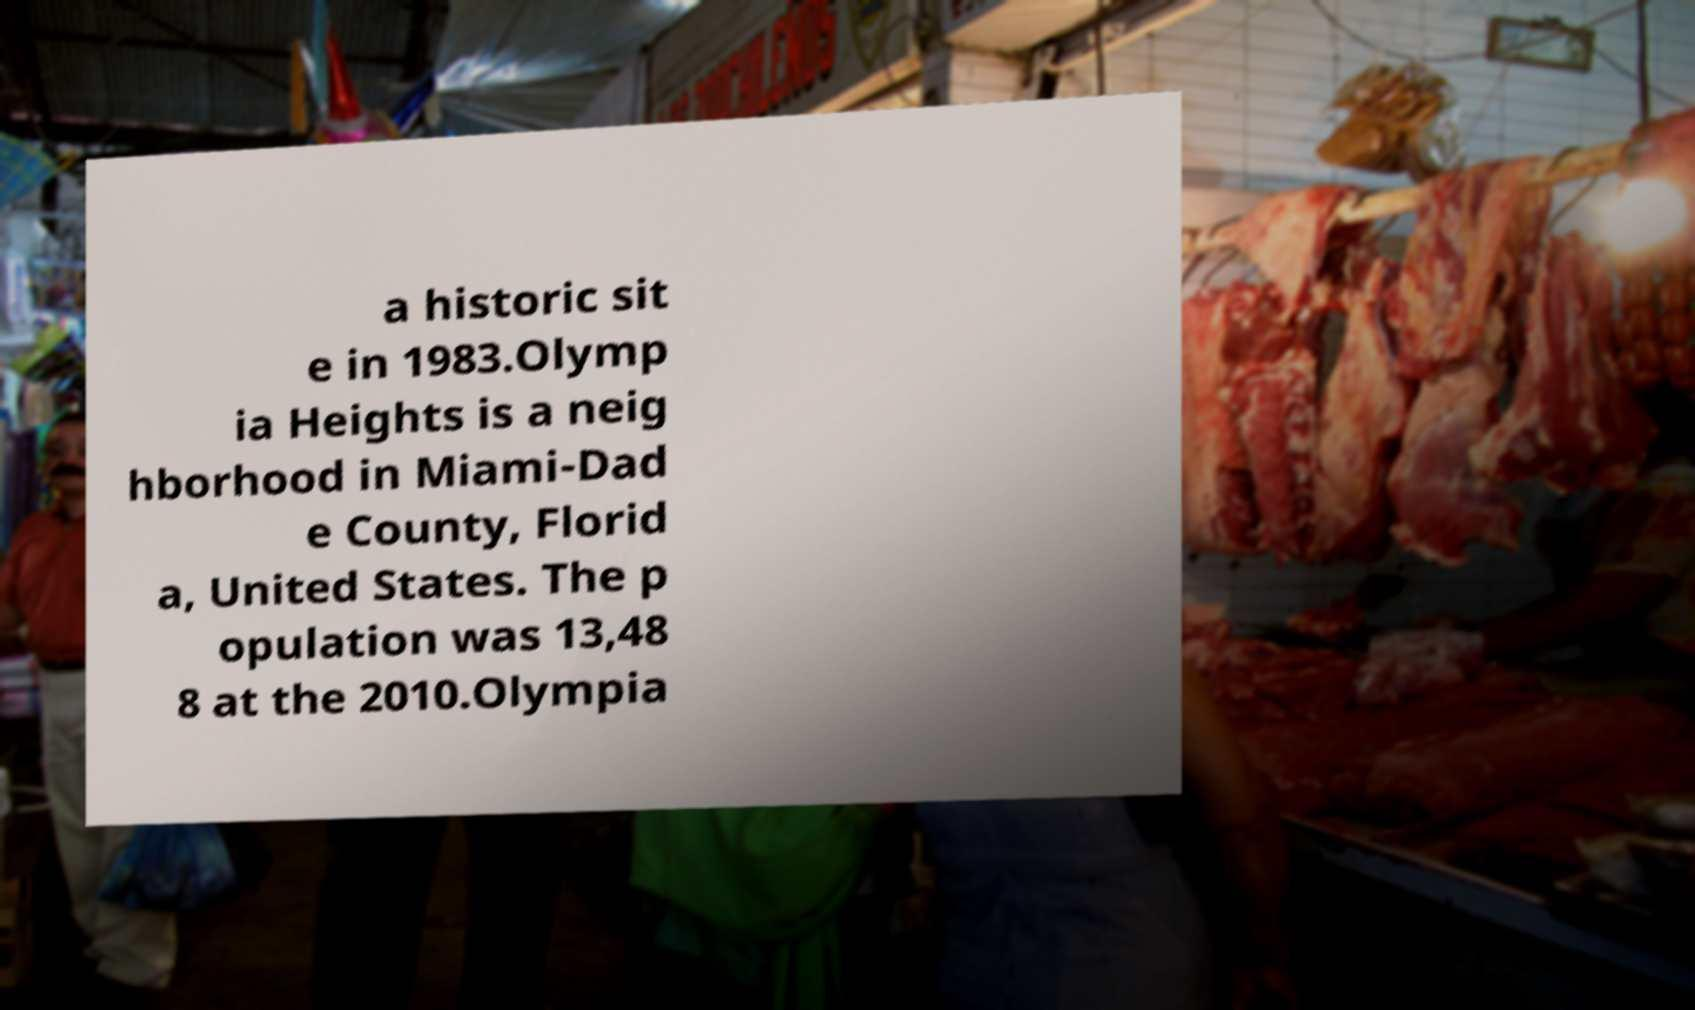What messages or text are displayed in this image? I need them in a readable, typed format. a historic sit e in 1983.Olymp ia Heights is a neig hborhood in Miami-Dad e County, Florid a, United States. The p opulation was 13,48 8 at the 2010.Olympia 